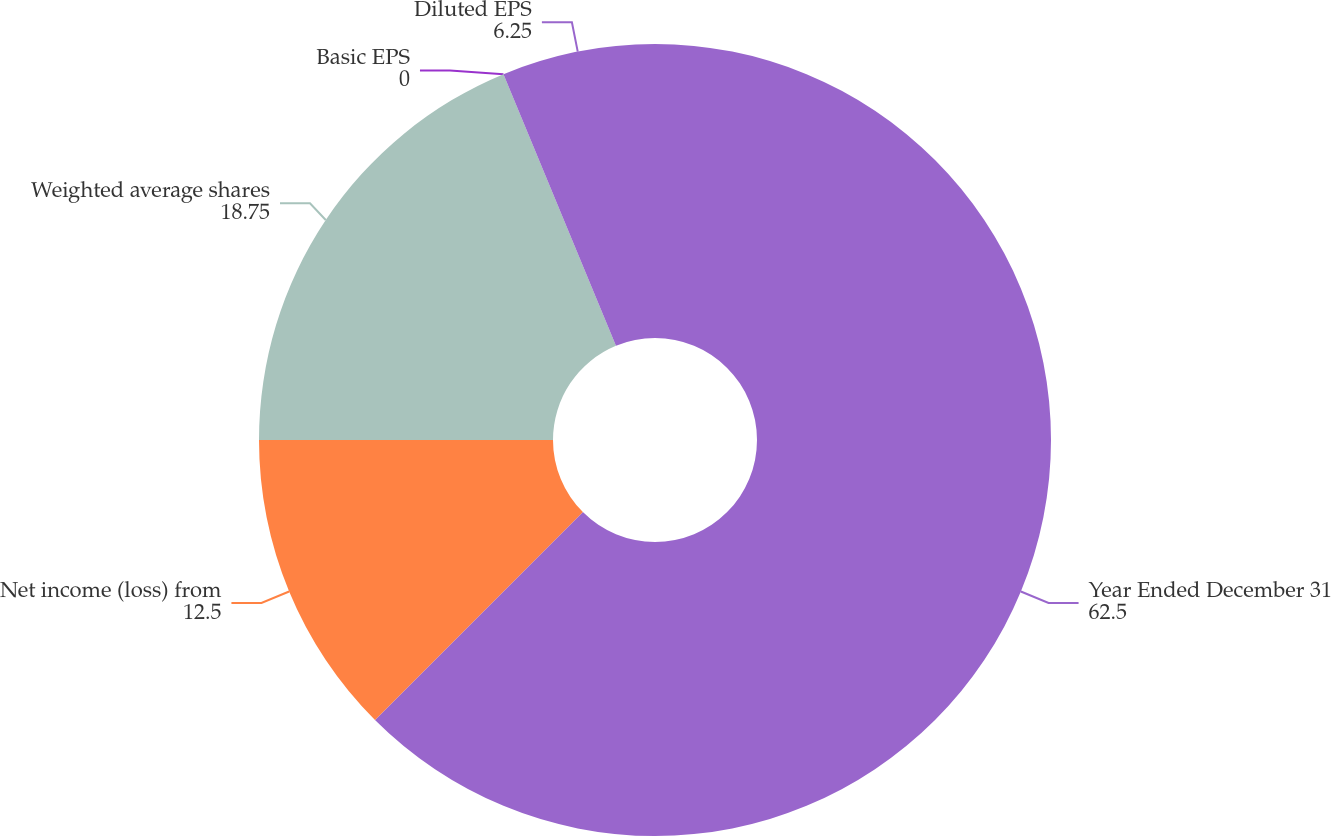Convert chart. <chart><loc_0><loc_0><loc_500><loc_500><pie_chart><fcel>Year Ended December 31<fcel>Net income (loss) from<fcel>Weighted average shares<fcel>Basic EPS<fcel>Diluted EPS<nl><fcel>62.5%<fcel>12.5%<fcel>18.75%<fcel>0.0%<fcel>6.25%<nl></chart> 